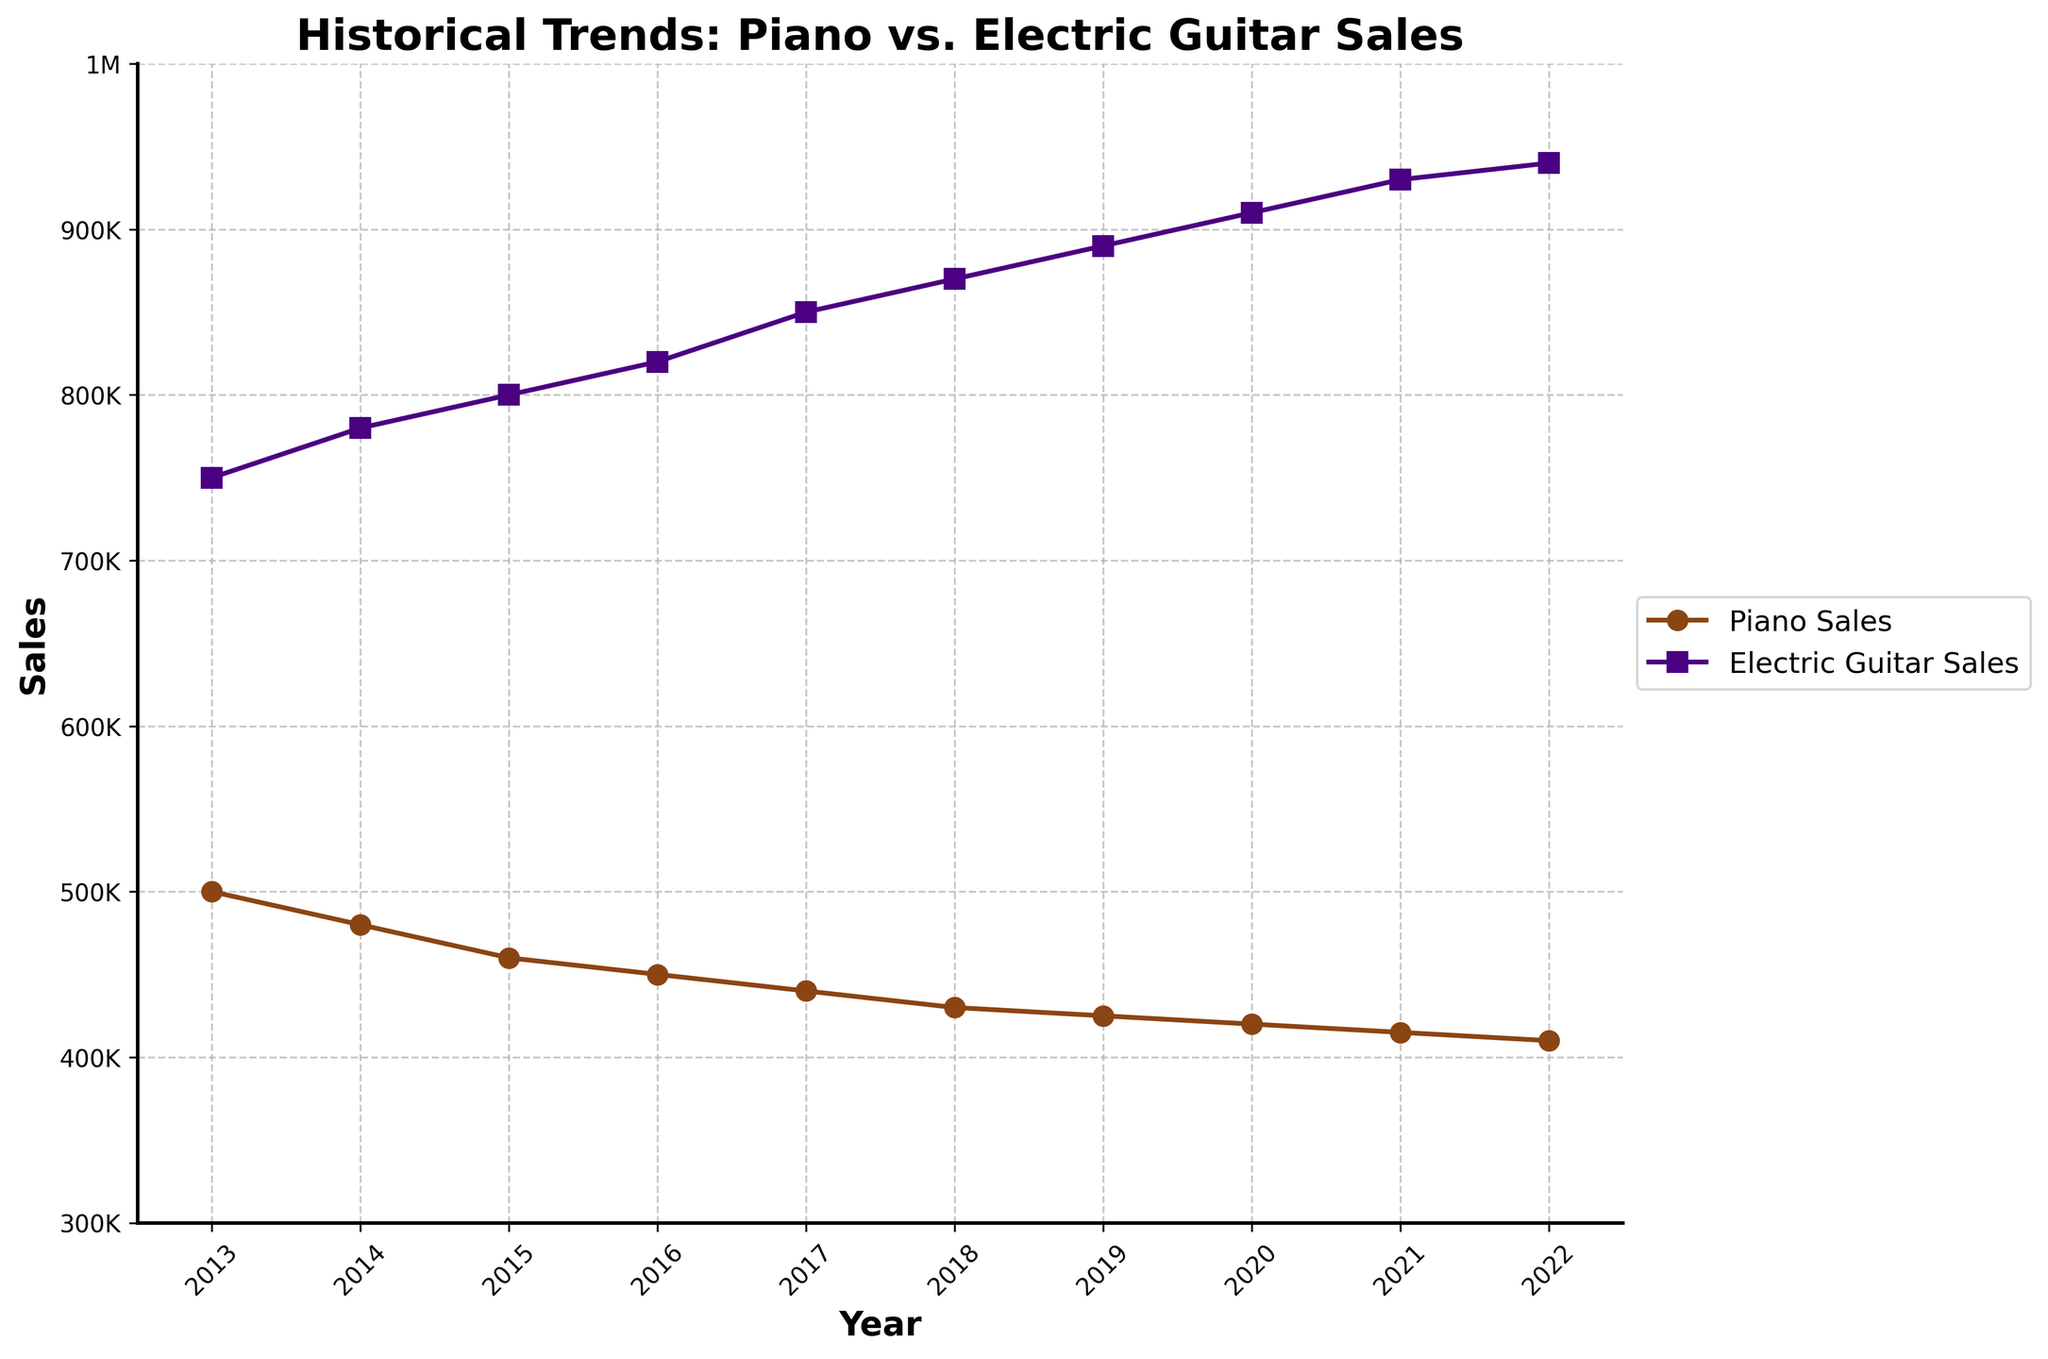What's the title of the plot? The title of the plot is displayed at the top and summarizes the main subject of the chart.
Answer: Historical Trends: Piano vs. Electric Guitar Sales What is the label for the y-axis? The y-axis label indicates the variable being measured along the axis.
Answer: Sales How many data points are there for each type of sales? By counting the number of markers along each line in the plot.
Answer: 10 Which year shows the highest electric guitar sales? By looking for the peak point on the line representing electric guitar sales.
Answer: 2022 What is the difference in electric guitar sales between 2013 and 2022? Find the sales values for electric guitars in 2013 and 2022 and subtract the earlier value from the later value: 940,000 - 750,000.
Answer: 190,000 What is the general trend of piano sales over the past decade? Observe the direction and shape of the line representing piano sales over the years.
Answer: Decreasing Which year has the smallest gap between piano sales and electric guitar sales? For each year, calculate the absolute difference between the piano and electric guitar sales and find the year with the smallest difference.
Answer: 2013 By how much did piano sales decrease from 2013 to 2022? Find the sales values for pianos in 2013 and 2022 and subtract the later value from the earlier value: 500,000 - 410,000.
Answer: 90,000 Compare the trends of piano sales and electric guitar sales. Observe and contrast the directions of the lines for both piano and electric guitar sales over the years.
Answer: Piano sales decrease while electric guitar sales increase 